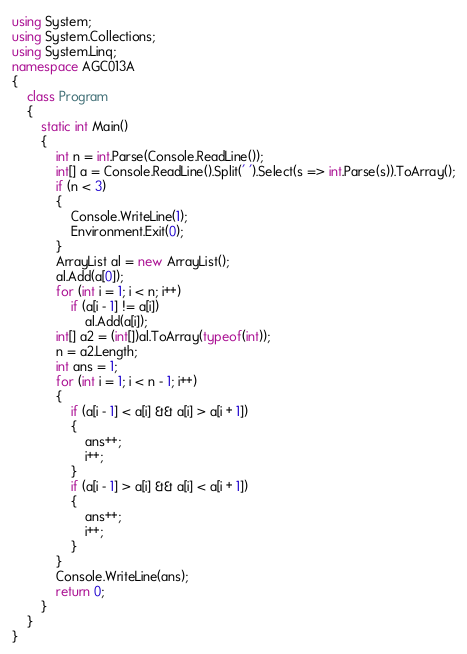Convert code to text. <code><loc_0><loc_0><loc_500><loc_500><_C#_>using System;
using System.Collections;
using System.Linq;
namespace AGC013A
{
    class Program
    {
        static int Main()
        {
            int n = int.Parse(Console.ReadLine());
            int[] a = Console.ReadLine().Split(' ').Select(s => int.Parse(s)).ToArray();
            if (n < 3)
            {
                Console.WriteLine(1);
                Environment.Exit(0);
            }
            ArrayList al = new ArrayList();
            al.Add(a[0]);
            for (int i = 1; i < n; i++)
                if (a[i - 1] != a[i])
                    al.Add(a[i]);
            int[] a2 = (int[])al.ToArray(typeof(int));
            n = a2.Length;
            int ans = 1;
            for (int i = 1; i < n - 1; i++)
            {
                if (a[i - 1] < a[i] && a[i] > a[i + 1])
                {
                    ans++;
                    i++;
                }
                if (a[i - 1] > a[i] && a[i] < a[i + 1])
                {
                    ans++;
                    i++;
                }
            }
            Console.WriteLine(ans);
            return 0;
        }
    }
}</code> 